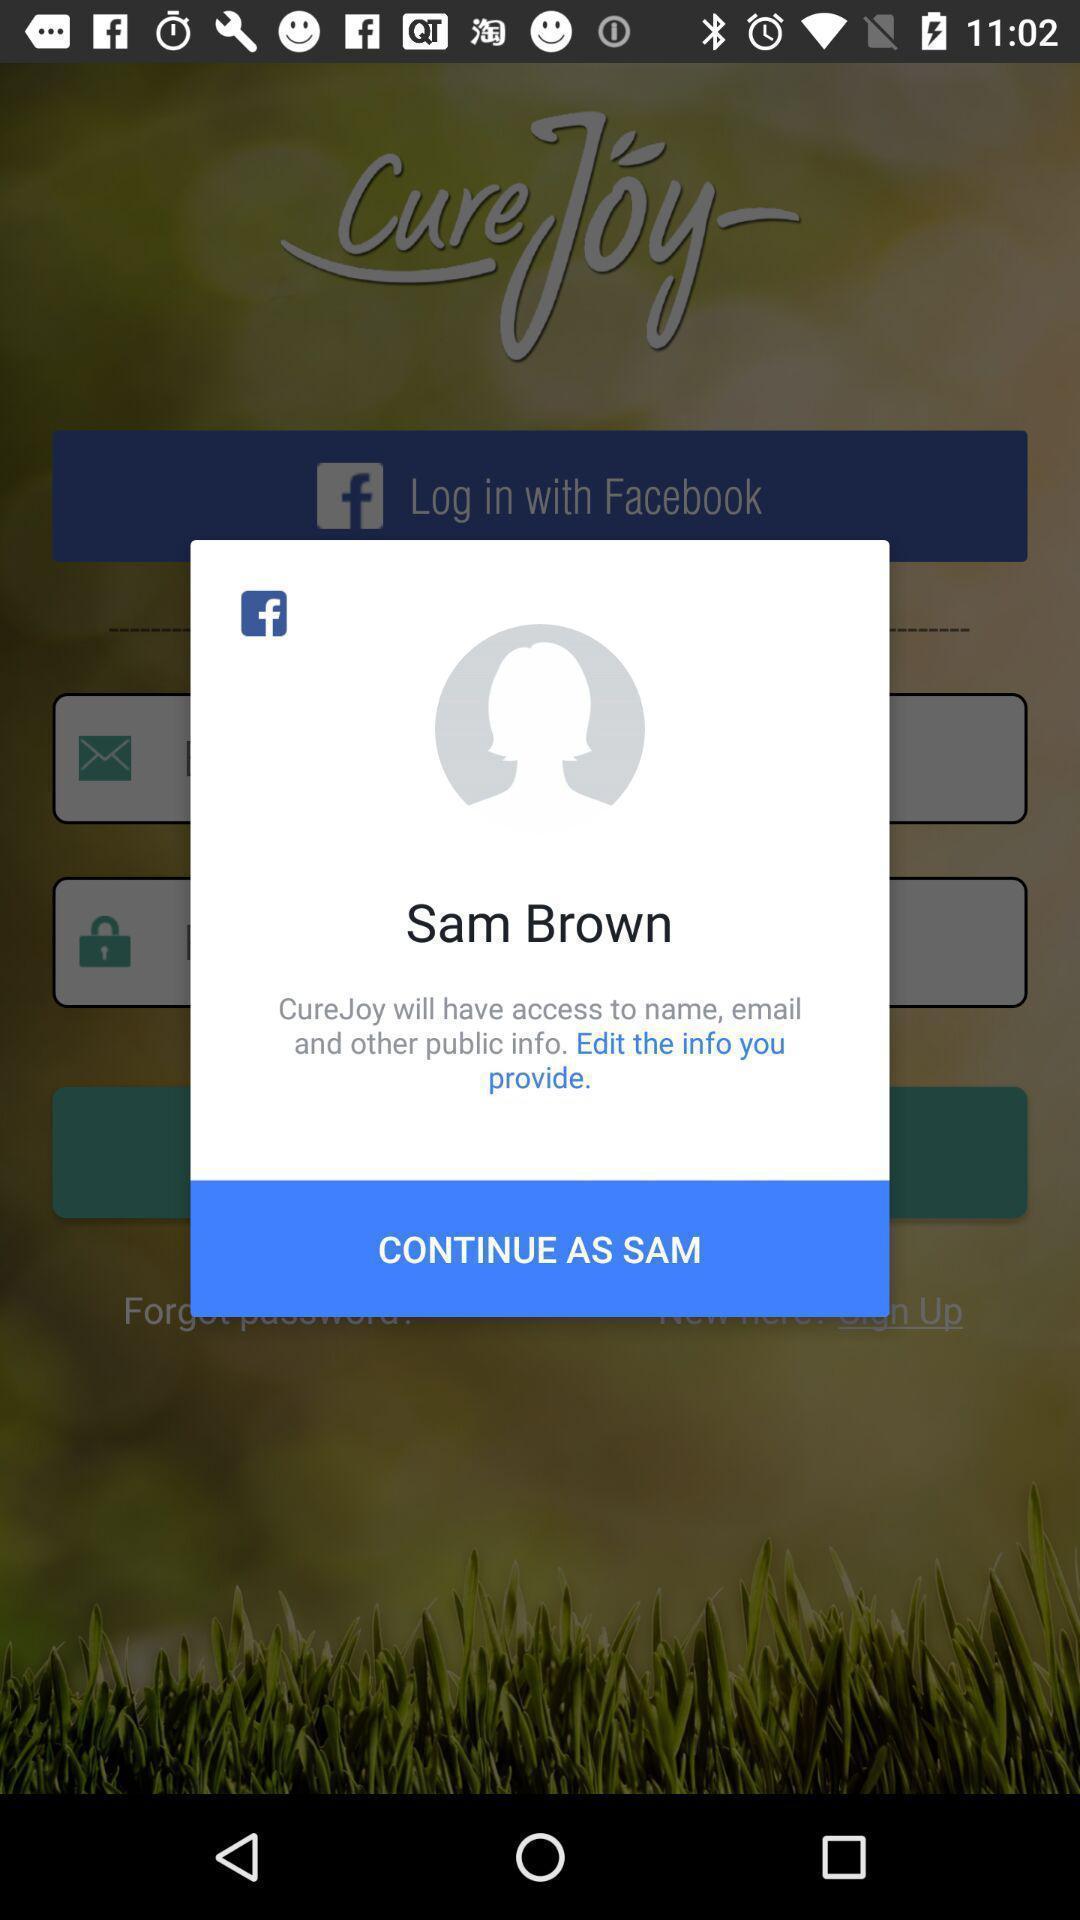Provide a textual representation of this image. Pop-up of a fitness app with social app. 